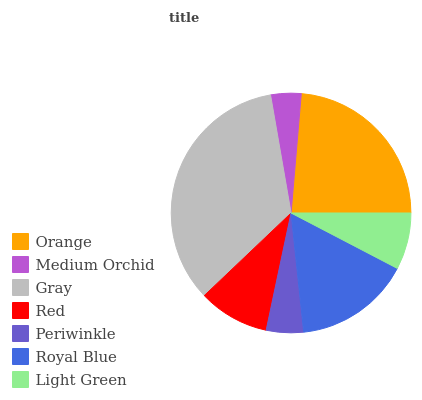Is Medium Orchid the minimum?
Answer yes or no. Yes. Is Gray the maximum?
Answer yes or no. Yes. Is Gray the minimum?
Answer yes or no. No. Is Medium Orchid the maximum?
Answer yes or no. No. Is Gray greater than Medium Orchid?
Answer yes or no. Yes. Is Medium Orchid less than Gray?
Answer yes or no. Yes. Is Medium Orchid greater than Gray?
Answer yes or no. No. Is Gray less than Medium Orchid?
Answer yes or no. No. Is Red the high median?
Answer yes or no. Yes. Is Red the low median?
Answer yes or no. Yes. Is Gray the high median?
Answer yes or no. No. Is Orange the low median?
Answer yes or no. No. 